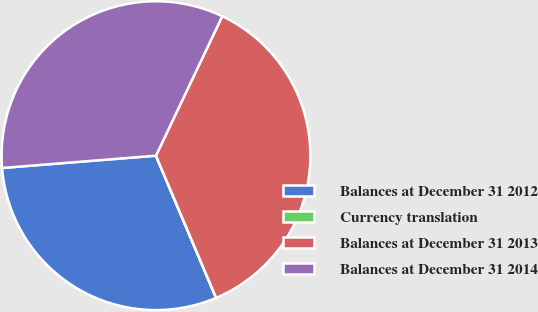<chart> <loc_0><loc_0><loc_500><loc_500><pie_chart><fcel>Balances at December 31 2012<fcel>Currency translation<fcel>Balances at December 31 2013<fcel>Balances at December 31 2014<nl><fcel>30.09%<fcel>0.01%<fcel>36.56%<fcel>33.33%<nl></chart> 